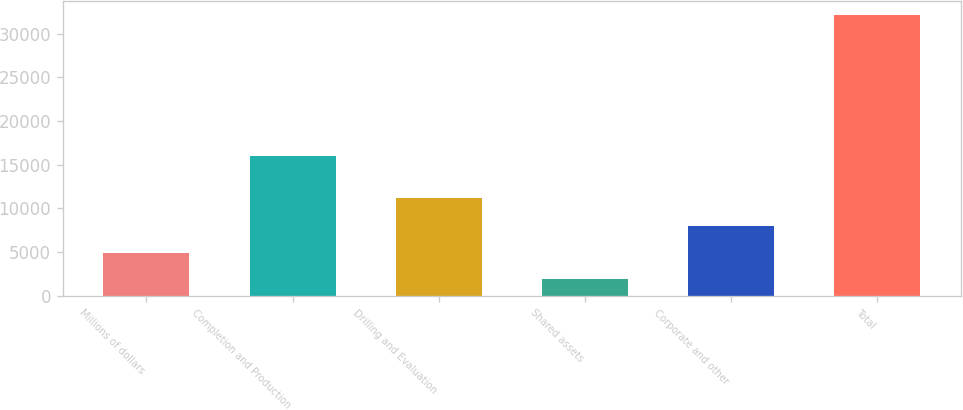Convert chart. <chart><loc_0><loc_0><loc_500><loc_500><bar_chart><fcel>Millions of dollars<fcel>Completion and Production<fcel>Drilling and Evaluation<fcel>Shared assets<fcel>Corporate and other<fcel>Total<nl><fcel>4953.5<fcel>16033<fcel>11237<fcel>1930<fcel>7977<fcel>32165<nl></chart> 